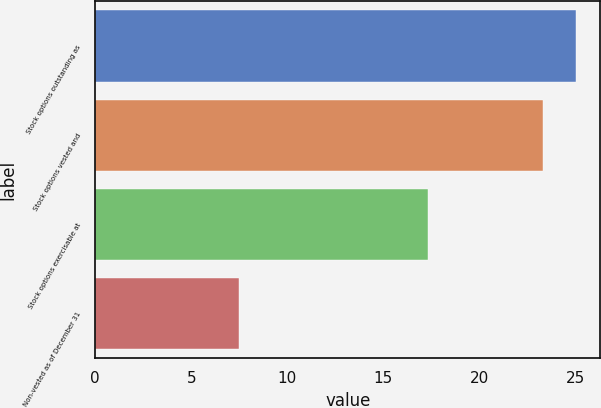Convert chart. <chart><loc_0><loc_0><loc_500><loc_500><bar_chart><fcel>Stock options outstanding as<fcel>Stock options vested and<fcel>Stock options exercisable at<fcel>Non-vested as of December 31<nl><fcel>25.03<fcel>23.3<fcel>17.3<fcel>7.5<nl></chart> 